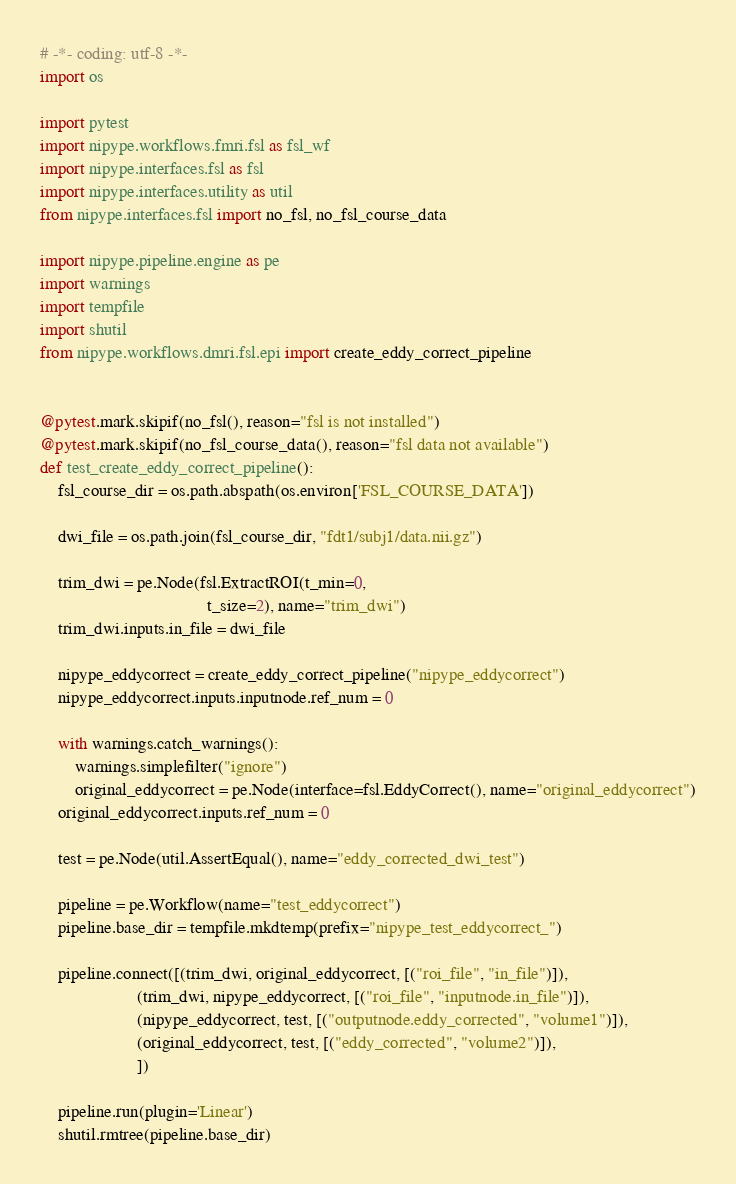Convert code to text. <code><loc_0><loc_0><loc_500><loc_500><_Python_># -*- coding: utf-8 -*-
import os

import pytest
import nipype.workflows.fmri.fsl as fsl_wf
import nipype.interfaces.fsl as fsl
import nipype.interfaces.utility as util
from nipype.interfaces.fsl import no_fsl, no_fsl_course_data

import nipype.pipeline.engine as pe
import warnings
import tempfile
import shutil
from nipype.workflows.dmri.fsl.epi import create_eddy_correct_pipeline


@pytest.mark.skipif(no_fsl(), reason="fsl is not installed")
@pytest.mark.skipif(no_fsl_course_data(), reason="fsl data not available")
def test_create_eddy_correct_pipeline():
    fsl_course_dir = os.path.abspath(os.environ['FSL_COURSE_DATA'])

    dwi_file = os.path.join(fsl_course_dir, "fdt1/subj1/data.nii.gz")

    trim_dwi = pe.Node(fsl.ExtractROI(t_min=0,
                                      t_size=2), name="trim_dwi")
    trim_dwi.inputs.in_file = dwi_file

    nipype_eddycorrect = create_eddy_correct_pipeline("nipype_eddycorrect")
    nipype_eddycorrect.inputs.inputnode.ref_num = 0

    with warnings.catch_warnings():
        warnings.simplefilter("ignore")
        original_eddycorrect = pe.Node(interface=fsl.EddyCorrect(), name="original_eddycorrect")
    original_eddycorrect.inputs.ref_num = 0

    test = pe.Node(util.AssertEqual(), name="eddy_corrected_dwi_test")

    pipeline = pe.Workflow(name="test_eddycorrect")
    pipeline.base_dir = tempfile.mkdtemp(prefix="nipype_test_eddycorrect_")

    pipeline.connect([(trim_dwi, original_eddycorrect, [("roi_file", "in_file")]),
                      (trim_dwi, nipype_eddycorrect, [("roi_file", "inputnode.in_file")]),
                      (nipype_eddycorrect, test, [("outputnode.eddy_corrected", "volume1")]),
                      (original_eddycorrect, test, [("eddy_corrected", "volume2")]),
                      ])

    pipeline.run(plugin='Linear')
    shutil.rmtree(pipeline.base_dir)
</code> 